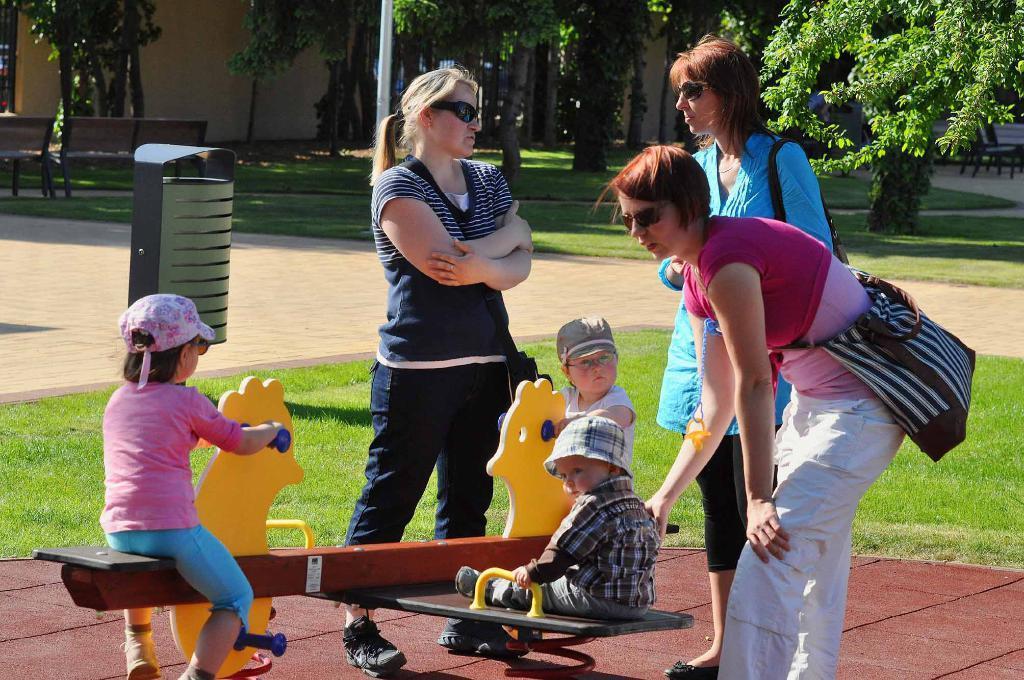How would you summarize this image in a sentence or two? In the image I can see three kids, people and around there are some trees, plants, poles, benches and some houses. 